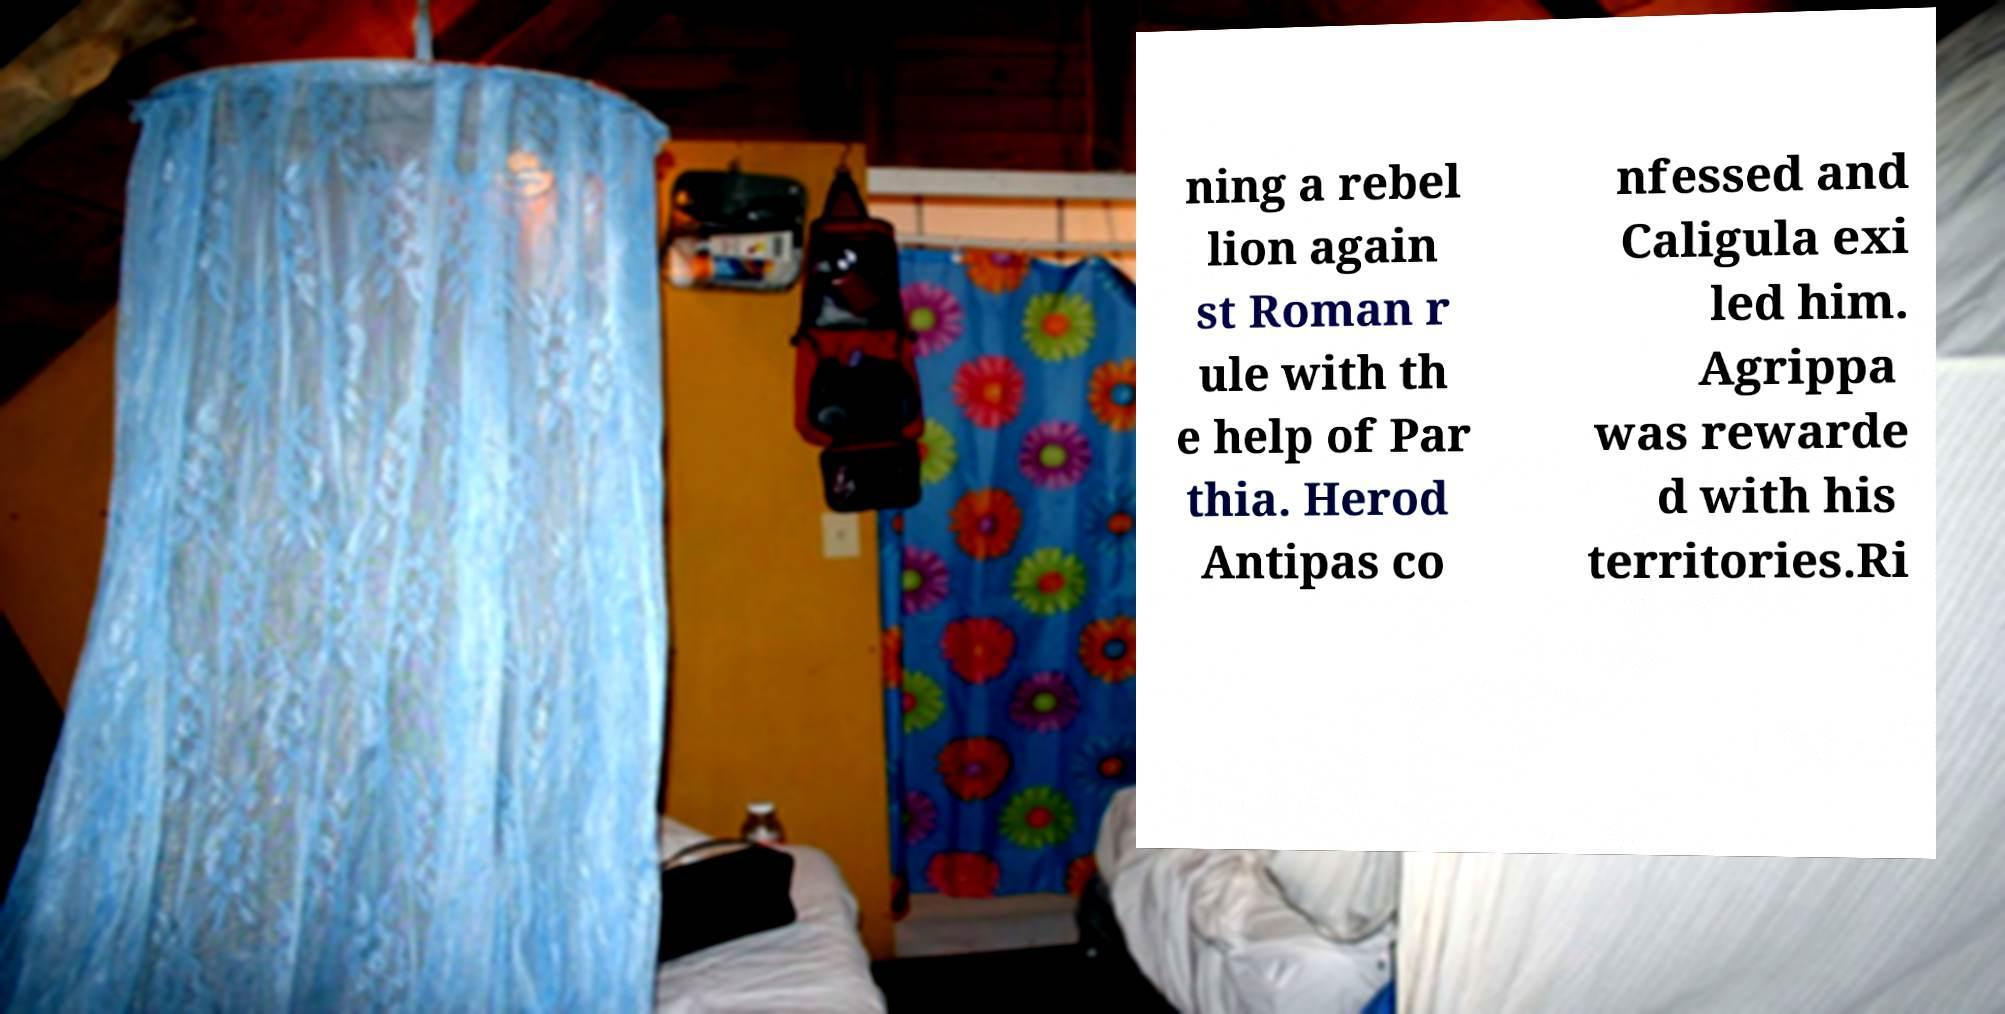Could you extract and type out the text from this image? ning a rebel lion again st Roman r ule with th e help of Par thia. Herod Antipas co nfessed and Caligula exi led him. Agrippa was rewarde d with his territories.Ri 